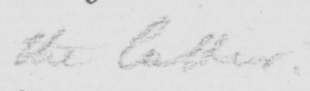Can you tell me what this handwritten text says? the latter , 